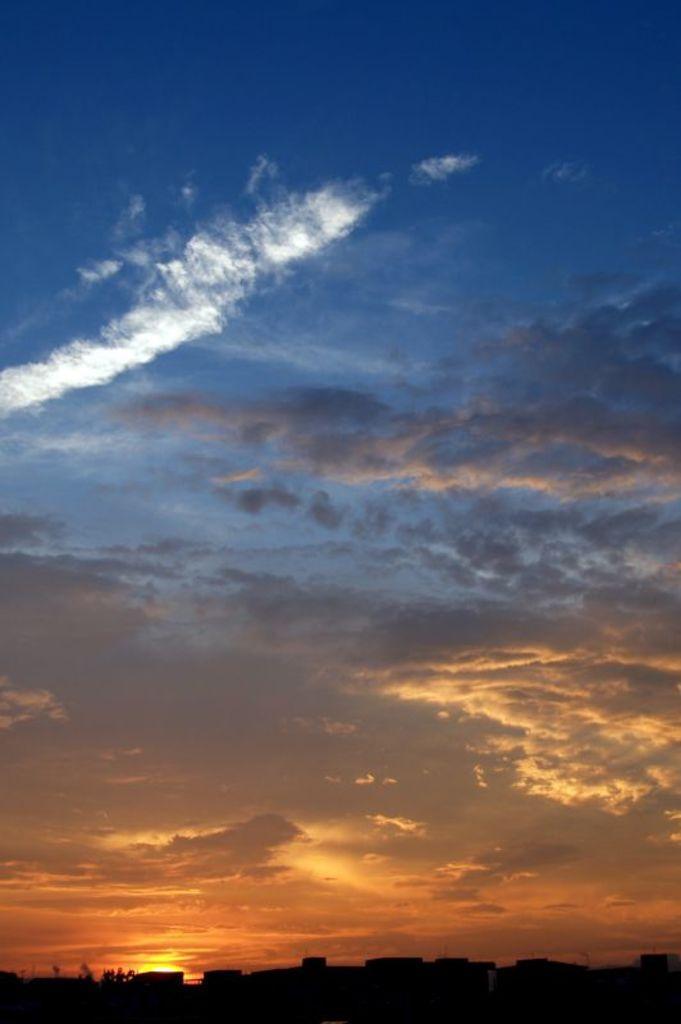How would you summarize this image in a sentence or two? In this picture we can see the sky with clouds. At the bottom of the image it is dark and we can see trees. 